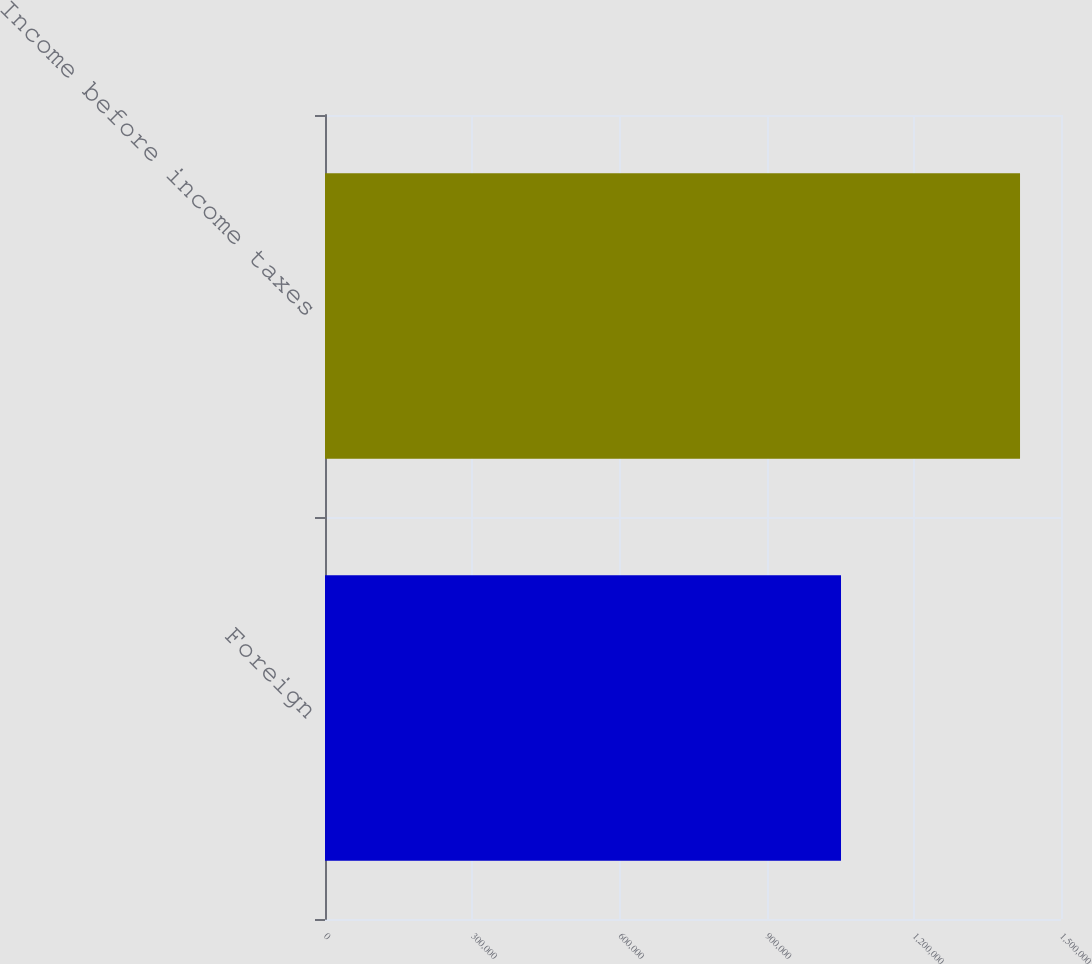Convert chart to OTSL. <chart><loc_0><loc_0><loc_500><loc_500><bar_chart><fcel>Foreign<fcel>Income before income taxes<nl><fcel>1.05165e+06<fcel>1.4165e+06<nl></chart> 